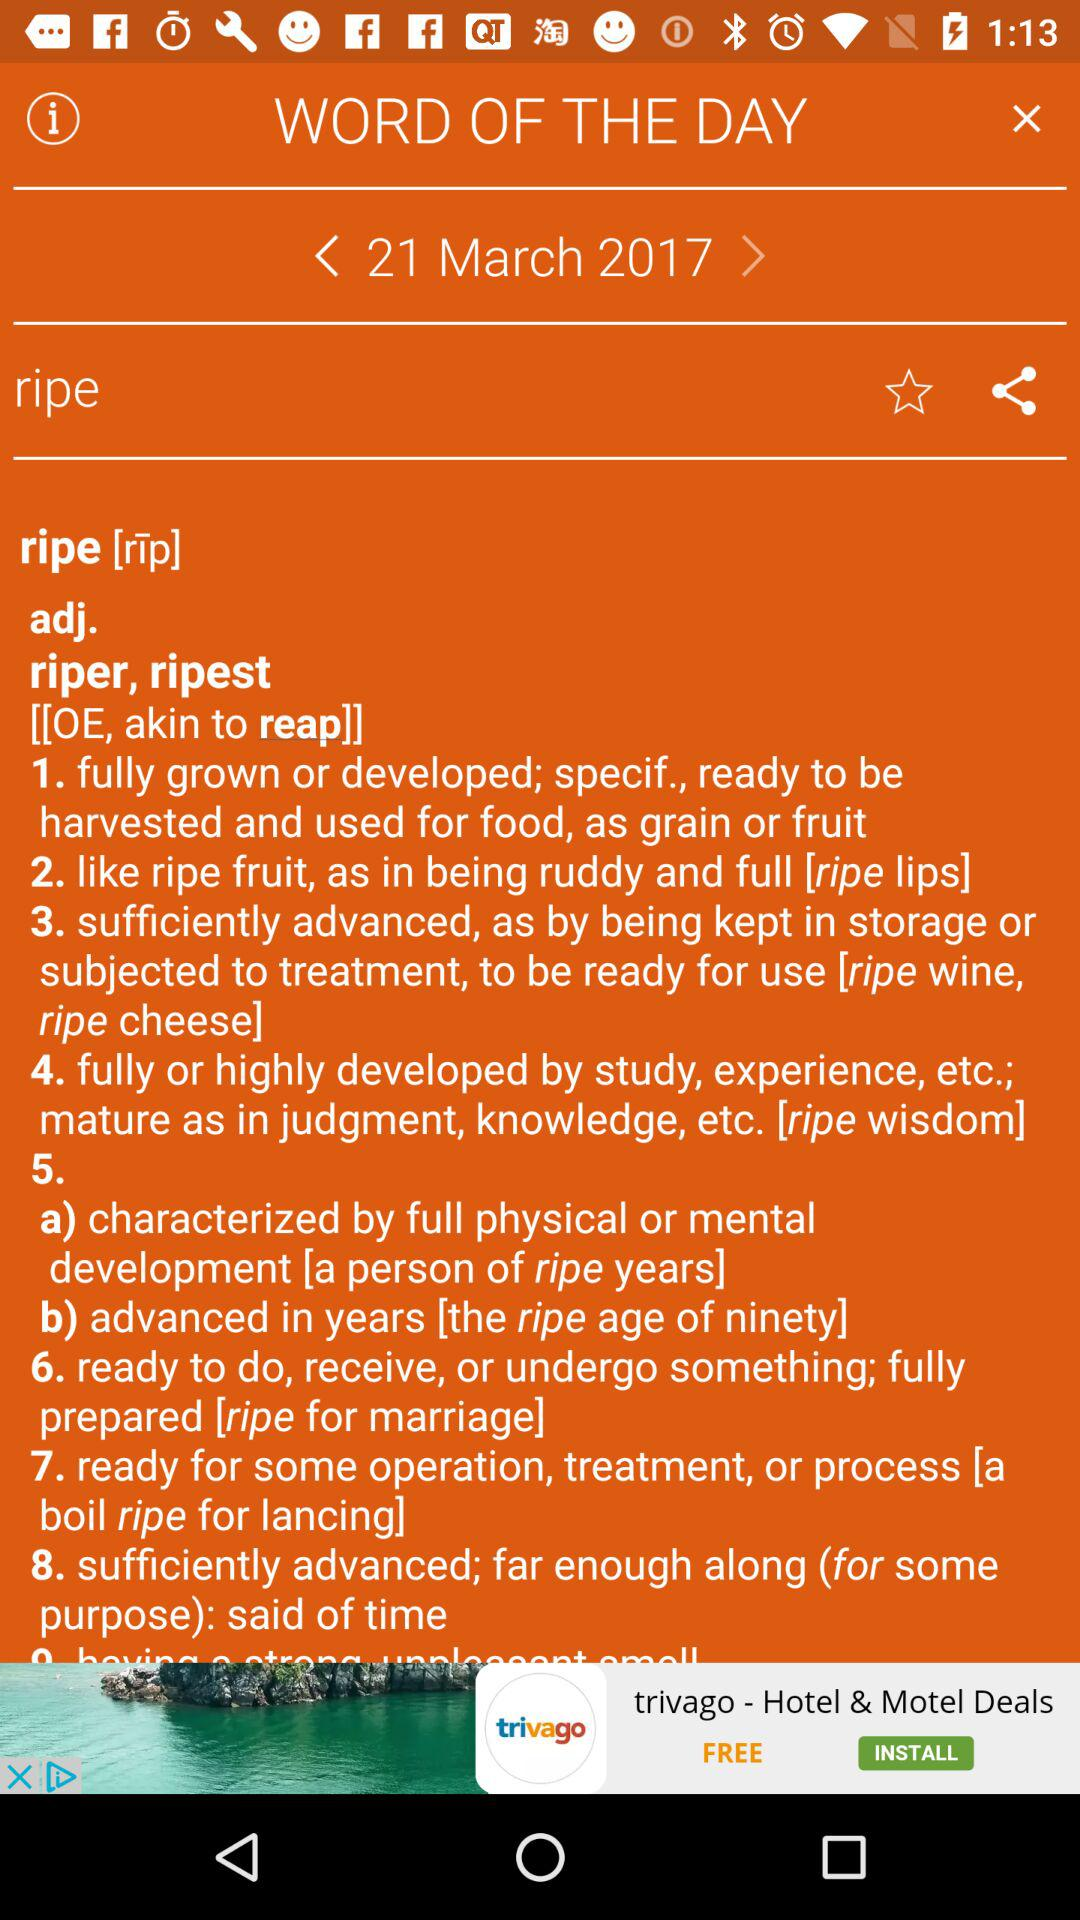What is the date? The date is March 21, 2017. 